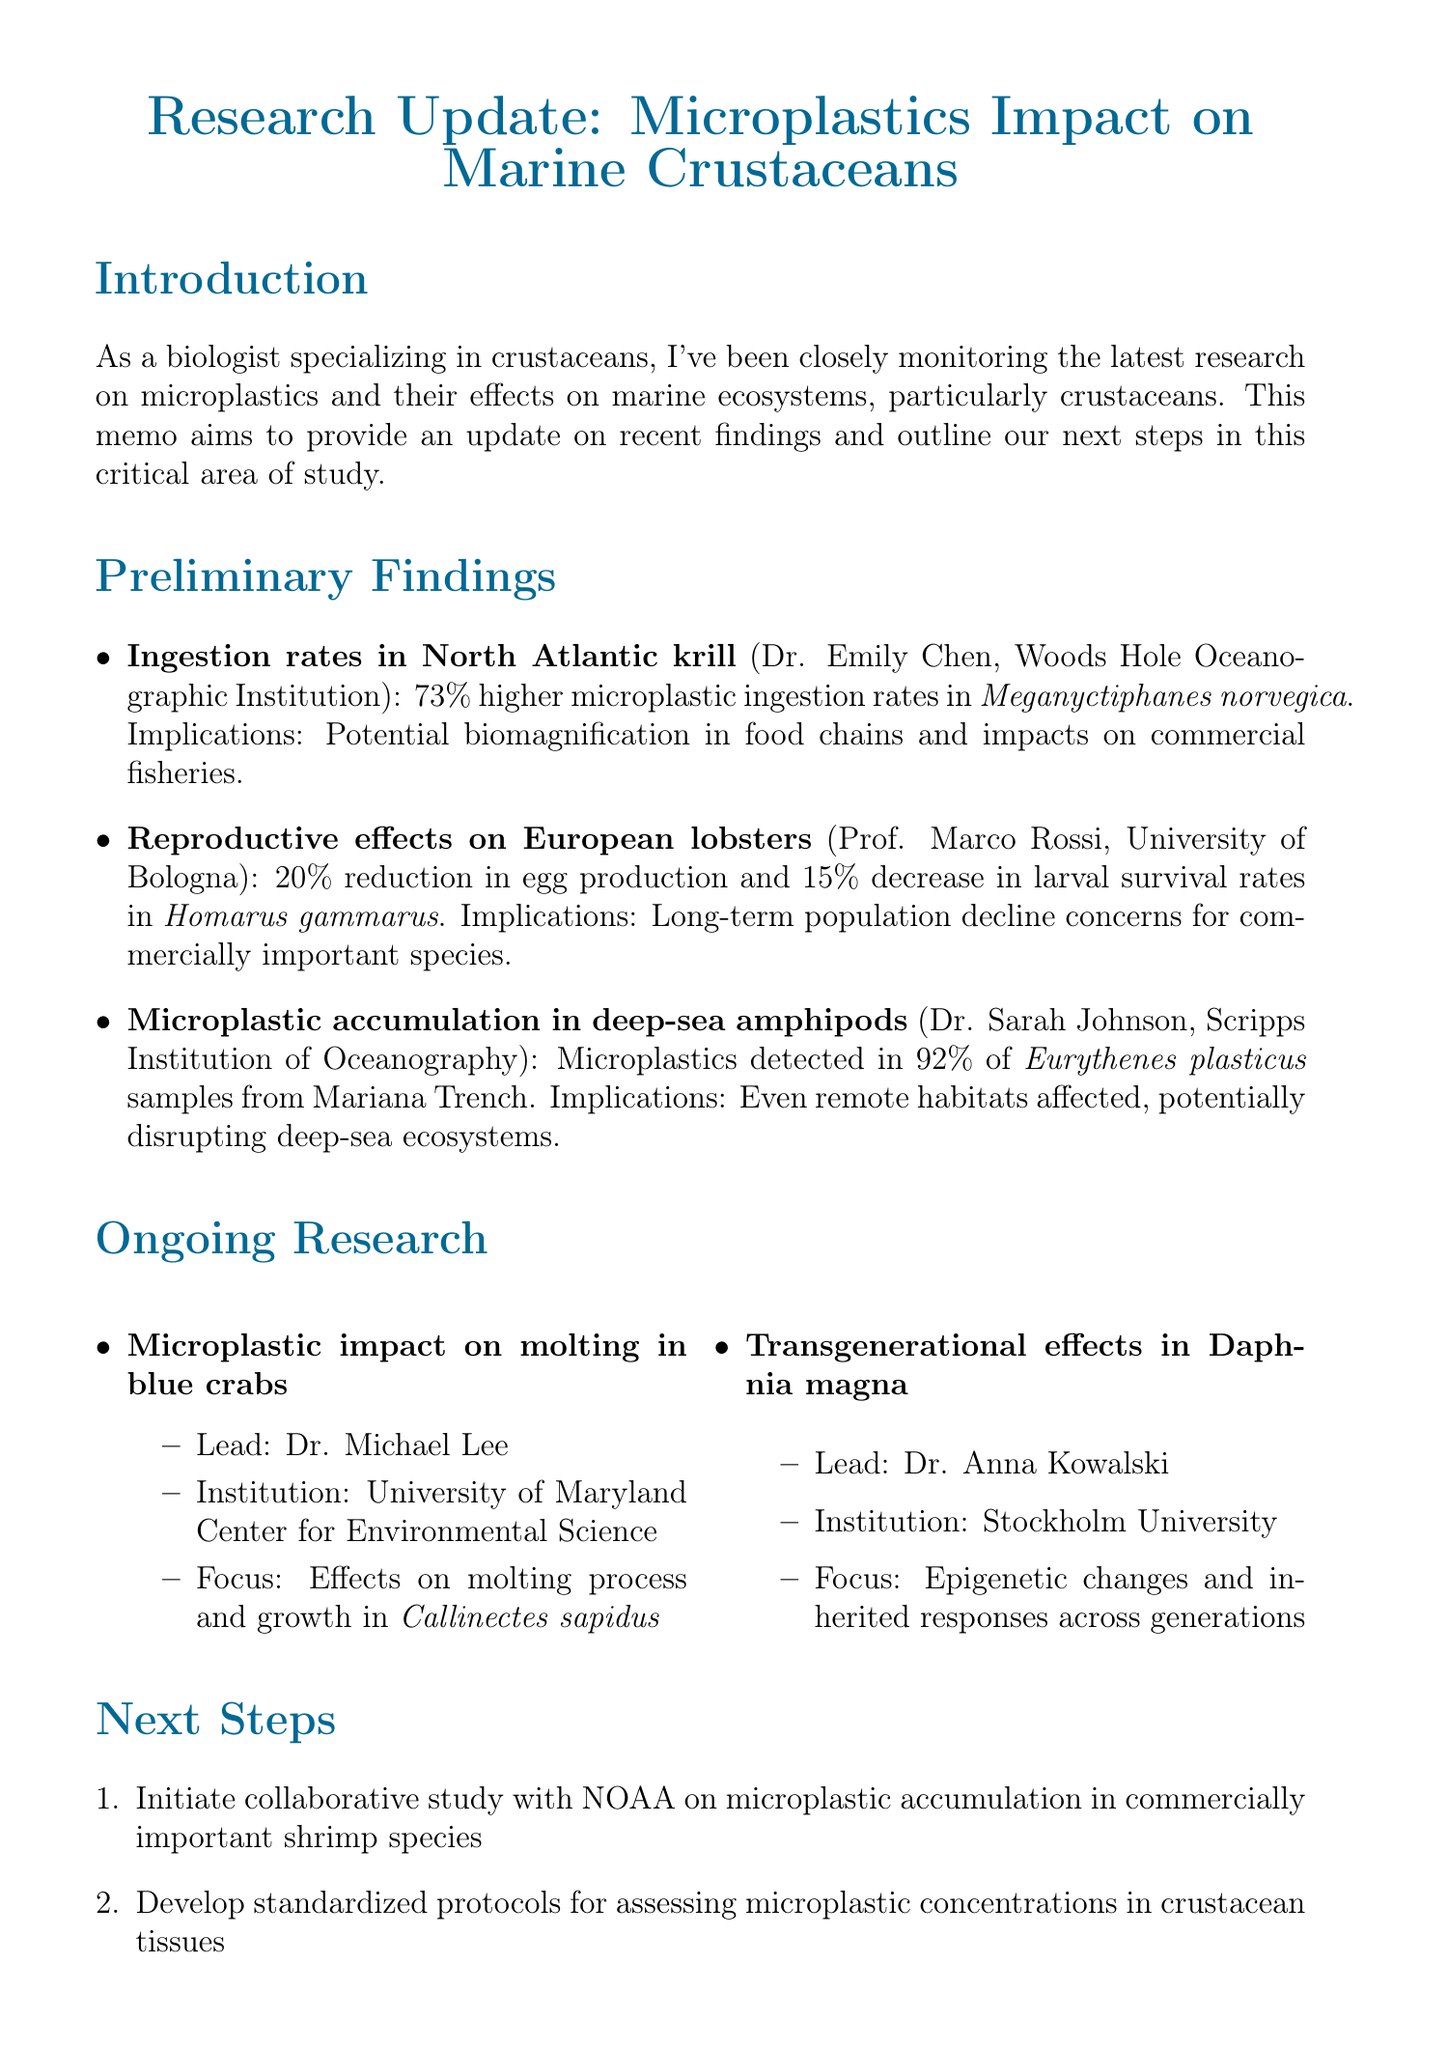What is the title of the memo? The title of the memo states the focus of the research update on microplastics and their impact on marine crustaceans.
Answer: Research Update: Microplastics Impact on Marine Crustaceans Who conducted the study on ingestion rates in North Atlantic krill? This study is attributed to Dr. Emily Chen and her team, highlighting their affiliation and focus on microplastic ingestion in krill.
Answer: Dr. Emily Chen What percentage increase in microplastic ingestion rates was observed in North Atlantic krill? The memo provides quantitative data regarding the ingestion rates, showing a significant change from previous estimates.
Answer: 73% What are the reproductive effects observed in European lobsters? The document specifies the impact of microplastics on egg production and larval survival in lobsters exposed to high concentrations.
Answer: 20% reduction in egg production and 15% decrease in larval survival rates What is the next step regarding shrimp species? The memo outlines a collaborative effort to study microplastic accumulation in shrimp, which is vital for understanding broader ecological impacts.
Answer: Initiate collaborative study with NOAA on microplastic accumulation in commercially important shrimp species Which researcher is investigating the impact on molting in blue crabs? Identifying the lead researcher allows for insight into ongoing investigations and their specific focus areas regarding crustaceans.
Answer: Dr. Michael Lee What is the focus of ongoing research on Daphnia magna? This question seeks to clarify what specific genetic aspects are being examined in relation to microplastic exposure across generations.
Answer: Epigenetic changes and inherited responses to microplastic exposure What is the primary call to action mentioned in the conclusion? The memo makes a clear appeal for increased efforts to address the issues raised throughout the research, emphasizing the urgency of the matter.
Answer: Accelerate our efforts to understand and mitigate these effects 